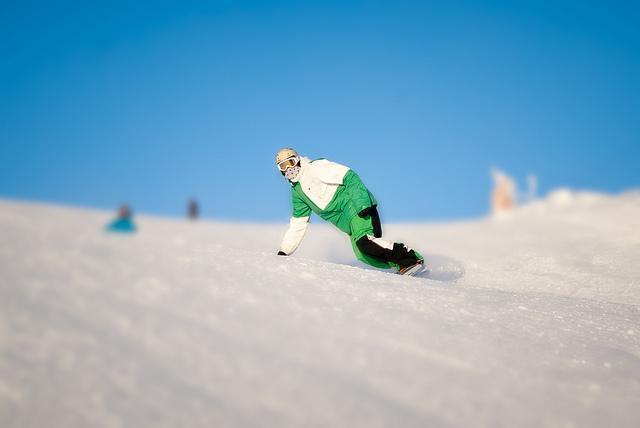How many people are in the picture?
Give a very brief answer. 1. 